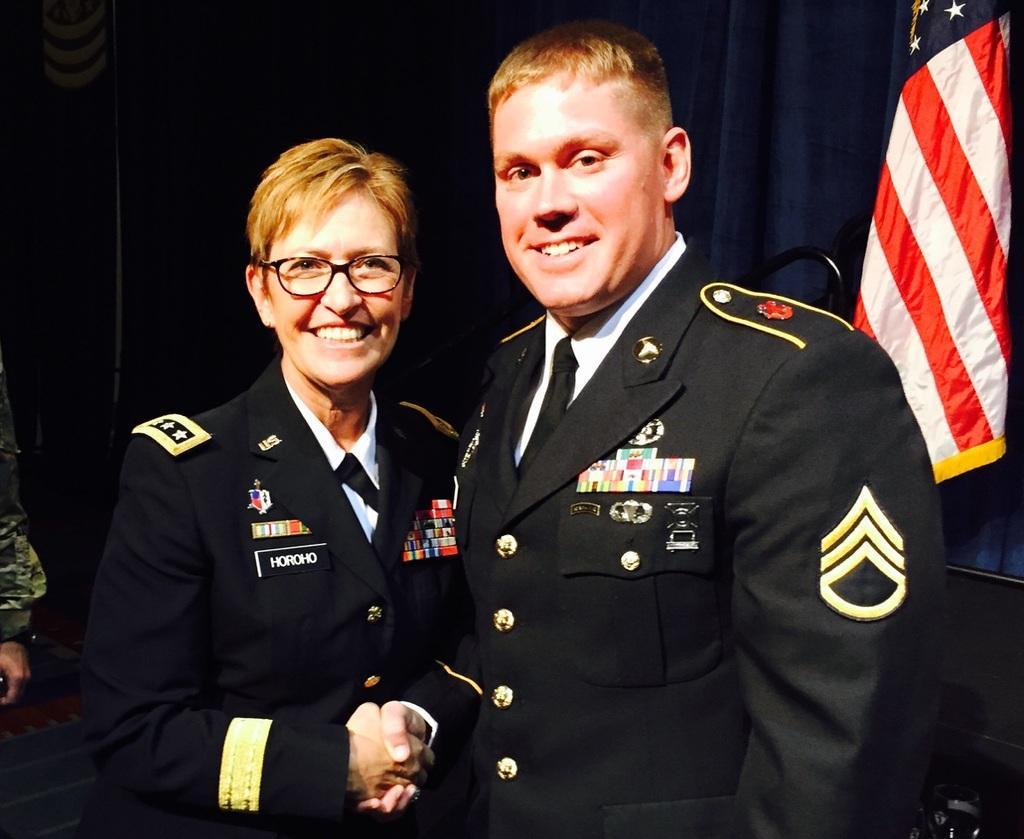Please provide a concise description of this image. In the picture we can see a man and a woman standing together, smiling and shaking hands and they are in uniforms, ties and shirts and behind them we can see blue color curtain and beside it we can see a flag and on the other side we can see a hand of a person. 